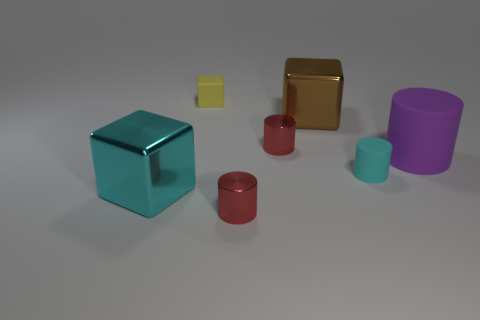Are the small yellow thing and the tiny cyan cylinder made of the same material?
Ensure brevity in your answer.  Yes. What number of other objects are the same material as the tiny yellow block?
Make the answer very short. 2. Are there more yellow rubber objects than large green matte things?
Provide a short and direct response. Yes. Do the cyan object behind the cyan shiny cube and the big cyan metallic object have the same shape?
Offer a very short reply. No. Are there fewer cyan rubber things than tiny blue cylinders?
Offer a terse response. No. There is a purple thing that is the same size as the brown metal object; what is its material?
Offer a terse response. Rubber. Does the small rubber cylinder have the same color as the large block behind the cyan rubber cylinder?
Your answer should be very brief. No. Are there fewer large purple things that are behind the big cyan cube than cylinders?
Offer a very short reply. Yes. What number of yellow objects are there?
Make the answer very short. 1. The cyan object that is on the left side of the red cylinder in front of the big cyan metallic thing is what shape?
Offer a very short reply. Cube. 